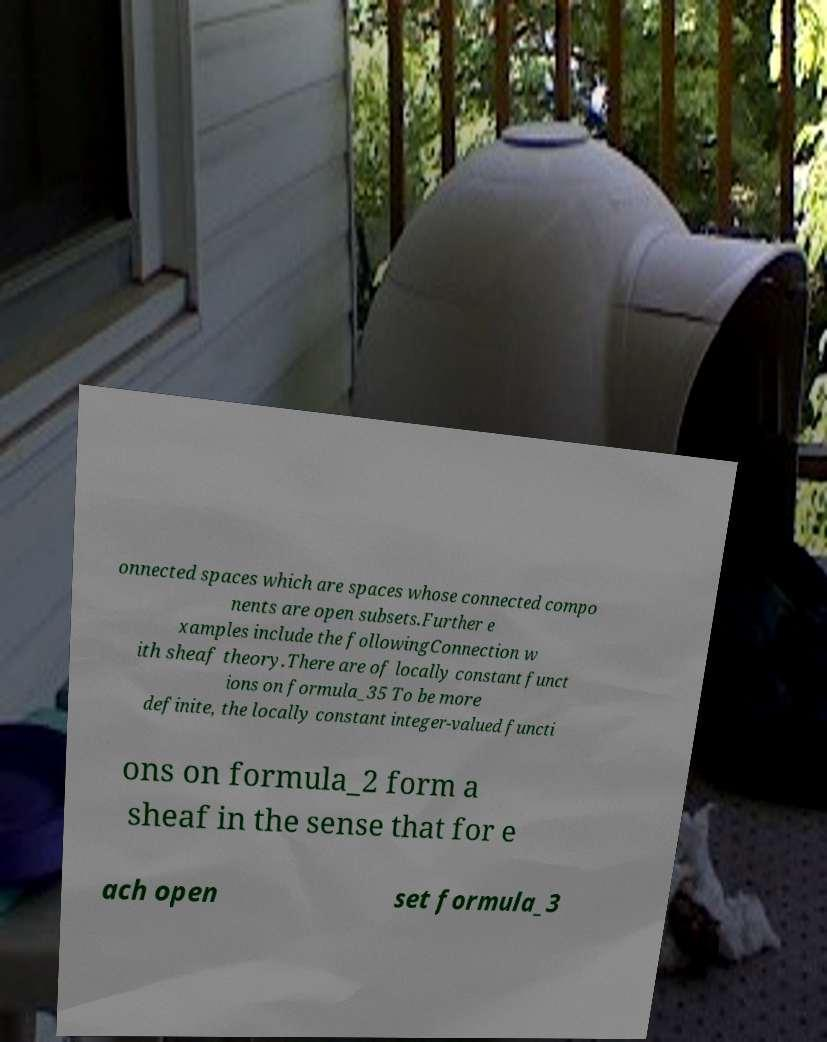Could you extract and type out the text from this image? onnected spaces which are spaces whose connected compo nents are open subsets.Further e xamples include the followingConnection w ith sheaf theory.There are of locally constant funct ions on formula_35 To be more definite, the locally constant integer-valued functi ons on formula_2 form a sheaf in the sense that for e ach open set formula_3 